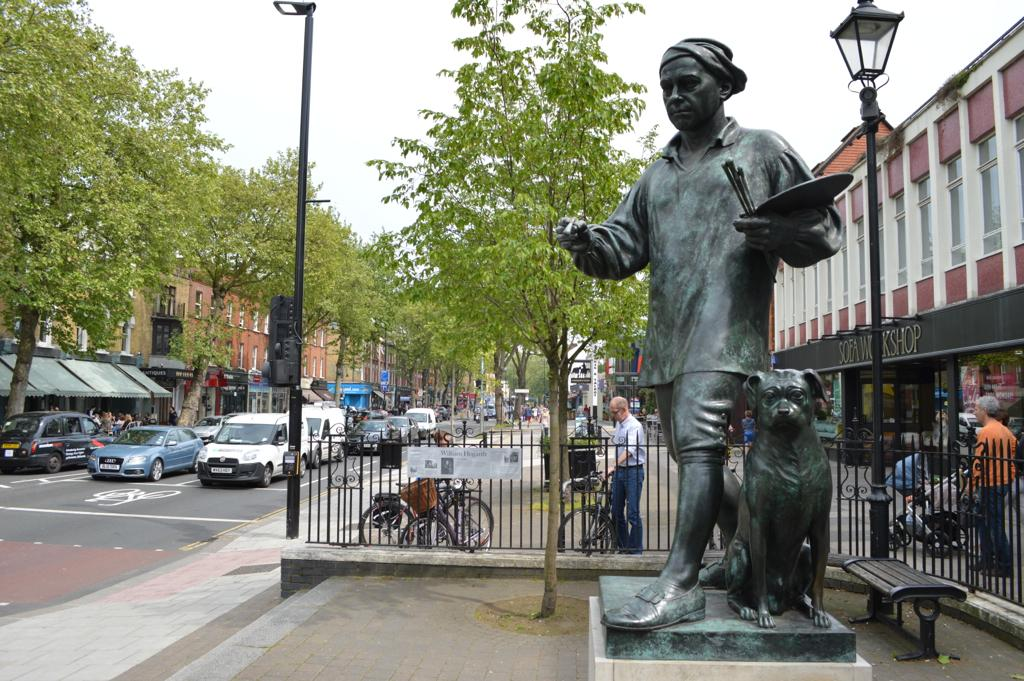What is the main subject in the foreground of the image? There is a sculpture in the foreground of the image. What can be seen in the background of the image? In the background of the image, there are poles, a bench, railing, trees, bicycles, vehicles, buildings, and the sky. Can you describe the setting of the image? The image appears to be set in an outdoor urban area with a sculpture in the foreground and various structures and objects in the background. What type of transportation is visible in the image? Vehicles are visible in the background of the image. What type of acoustics can be heard coming from the faucet in the image? There is no faucet present in the image, so it is not possible to determine the acoustics. 